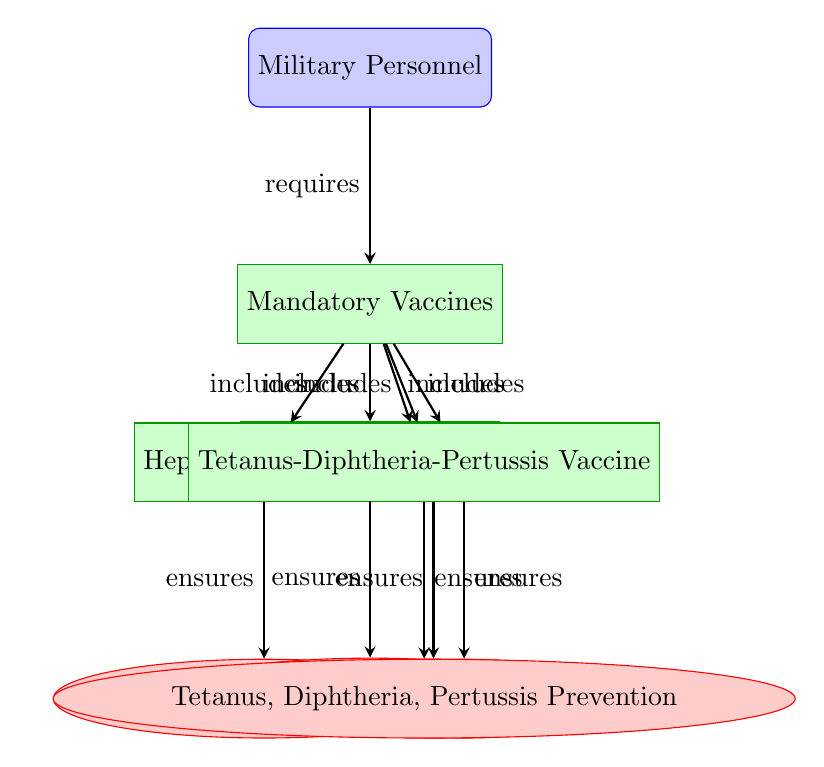What are the mandatory vaccines for military personnel? The diagram lists the mandatory vaccines, which include Influenza Vaccine, Hepatitis A Vaccine, Hepatitis B Vaccine, MMR Vaccine, and Tetanus-Diphtheria-Pertussis Vaccine.
Answer: Influenza Vaccine, Hepatitis A Vaccine, Hepatitis B Vaccine, MMR Vaccine, Tetanus-Diphtheria-Pertussis Vaccine How many vaccines are included under mandatory vaccines? By examining the diagram, there are a total of five vaccines listed under the "Mandatory Vaccines" node.
Answer: 5 What prevention does the Influenza Vaccine ensure? The diagram directly shows that the Influenza Vaccine ensures Influenza Prevention as an output.
Answer: Influenza Prevention Which vaccine ensures Tetanus, Diphtheria, and Pertussis Prevention? The diagram indicates that the Tetanus-Diphtheria-Pertussis Vaccine is the one that ensures Tetanus, Diphtheria, Pertussis Prevention.
Answer: Tetanus, Diphtheria, Pertussis Prevention Which vaccines are grouped together with Hepatitis B? The vaccines grouped with Hepatitis B are Influenza Vaccine, Hepatitis A Vaccine, MMR Vaccine, and Tetanus-Diphtheria-Pertussis Vaccine, as they are all connected to the "Mandatory Vaccines" node.
Answer: Influenza Vaccine, Hepatitis A Vaccine, MMR Vaccine, Tetanus-Diphtheria-Pertussis Vaccine What type of diagram is this? The diagram is a flowchart that outlines the immunization schedule and effectiveness for military personnel relating to mandatory vaccines.
Answer: Flowchart Which vaccine is at the top of the flowchart? The top of the flowchart, or the starting node, is labeled "Military Personnel."
Answer: Military Personnel What relationship is indicated between mandatory vaccines and their inclusiveness? The relationship is indicated by arrows that specify "includes" from the "Mandatory Vaccines" node to each of the individual vaccine nodes, representing the inclusion of those vaccines.
Answer: Includes 